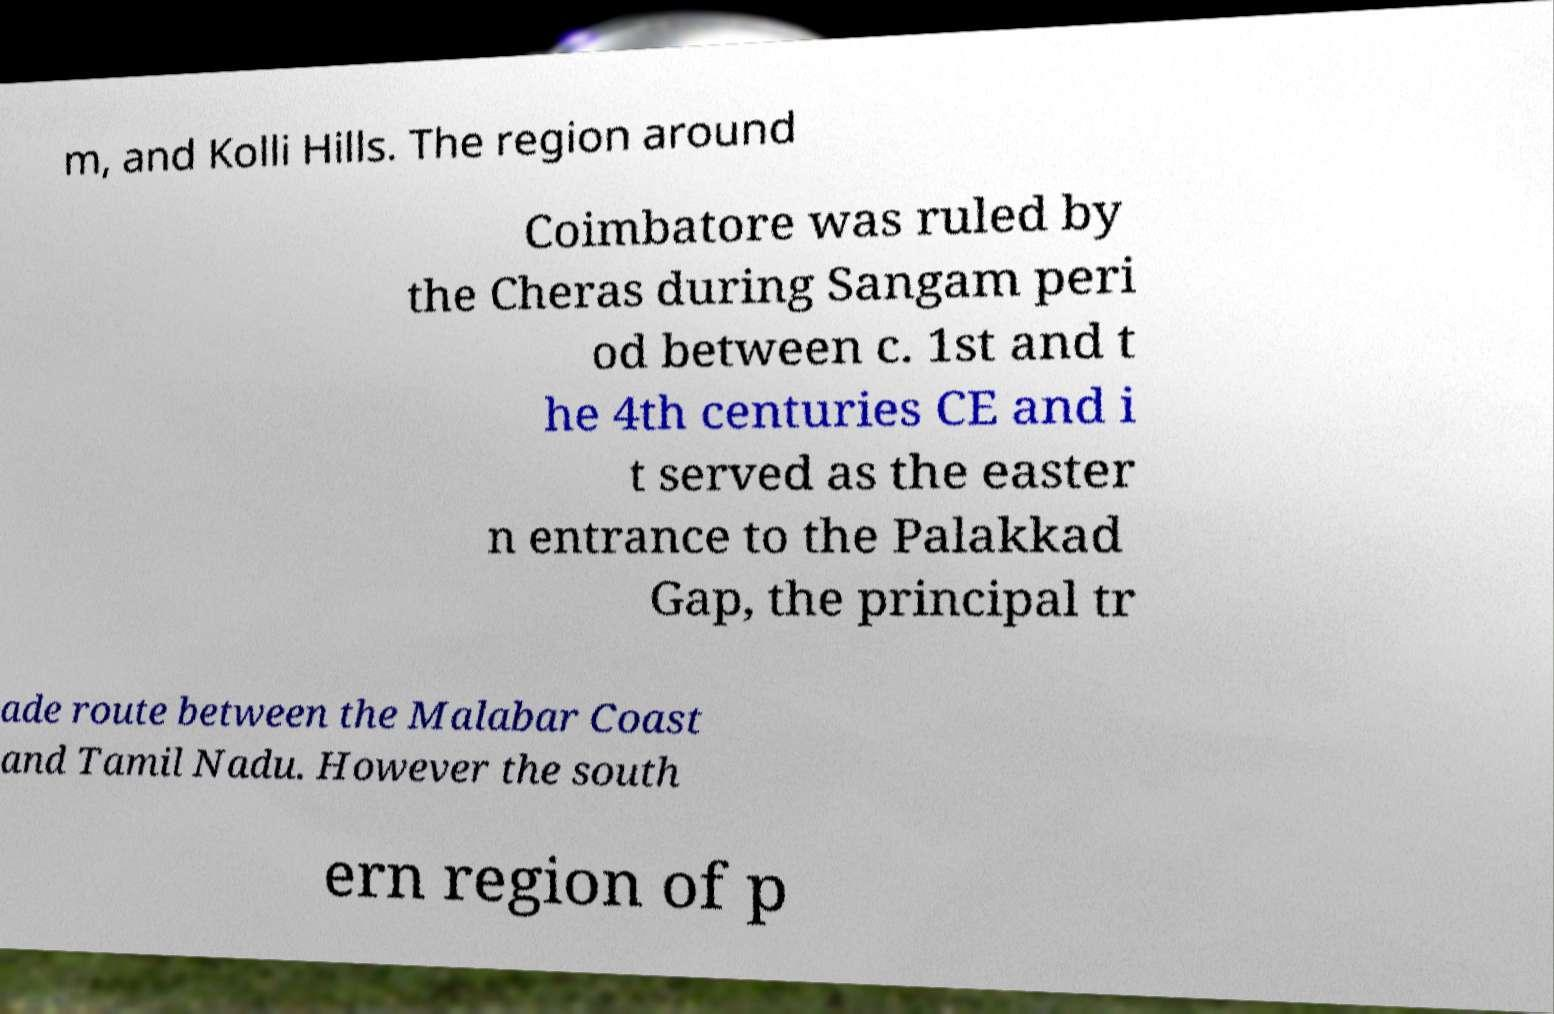What messages or text are displayed in this image? I need them in a readable, typed format. m, and Kolli Hills. The region around Coimbatore was ruled by the Cheras during Sangam peri od between c. 1st and t he 4th centuries CE and i t served as the easter n entrance to the Palakkad Gap, the principal tr ade route between the Malabar Coast and Tamil Nadu. However the south ern region of p 